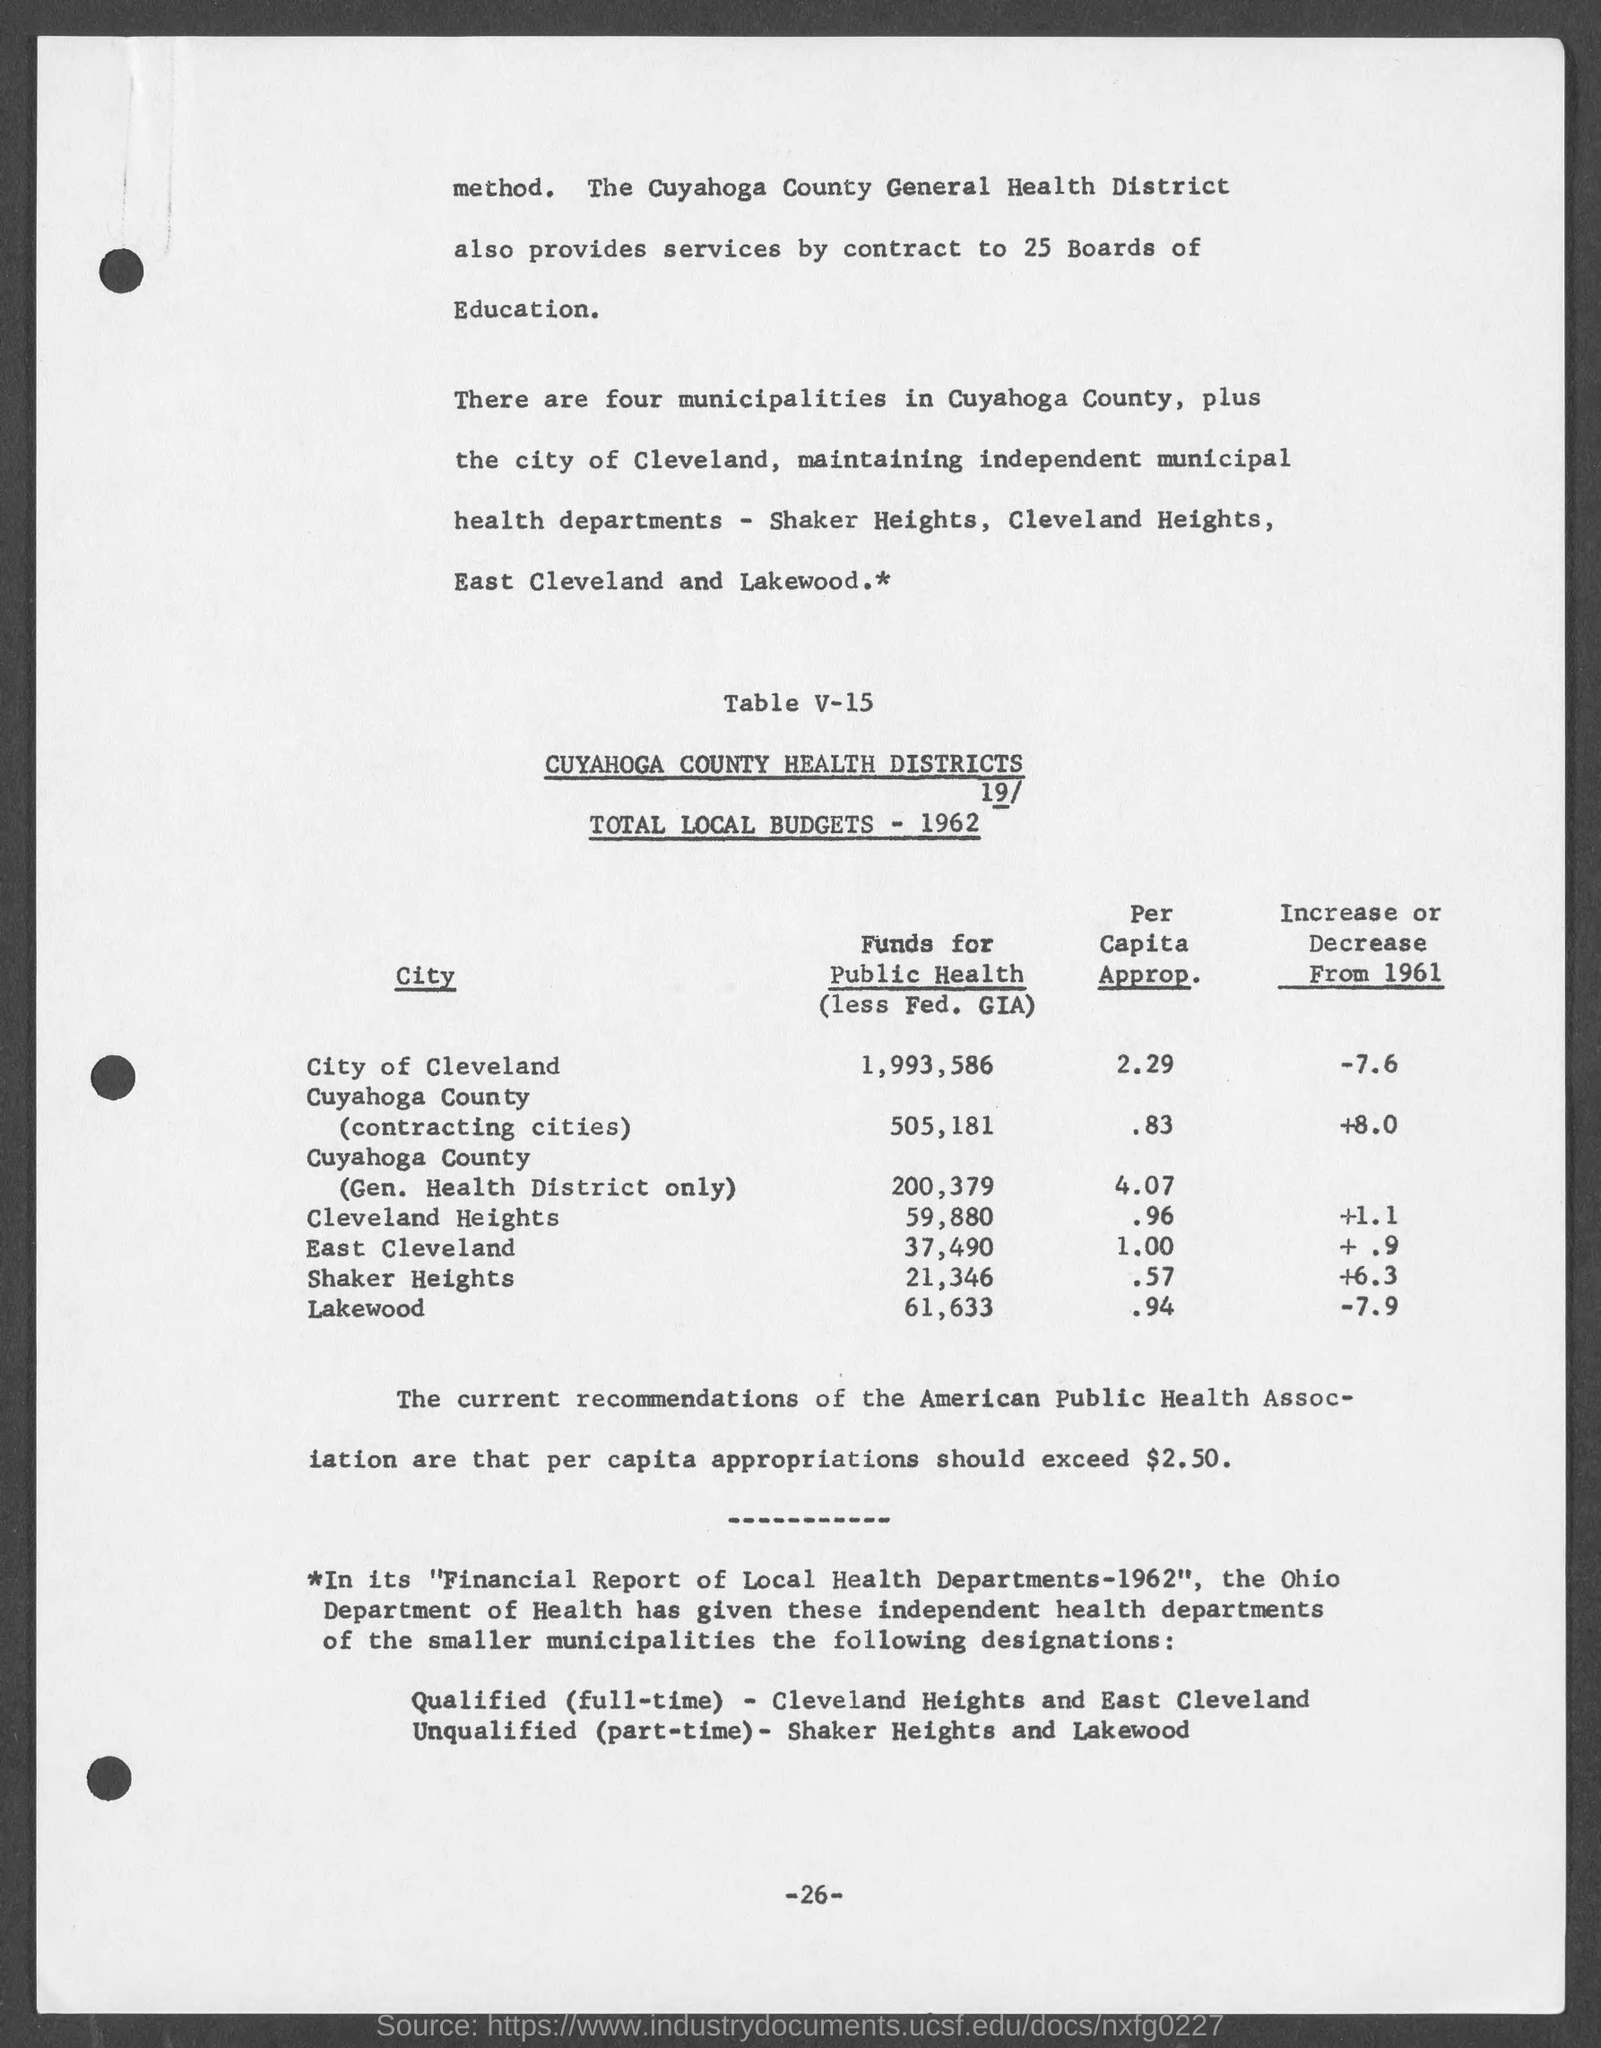Highlight a few significant elements in this photo. There are four municipalities in Cuyahoga County that maintain independent health departments. 